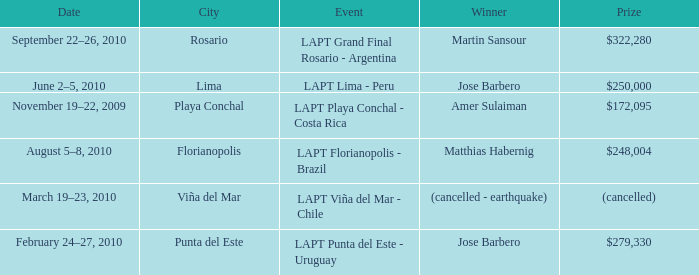What event has a $248,004 prize? LAPT Florianopolis - Brazil. 